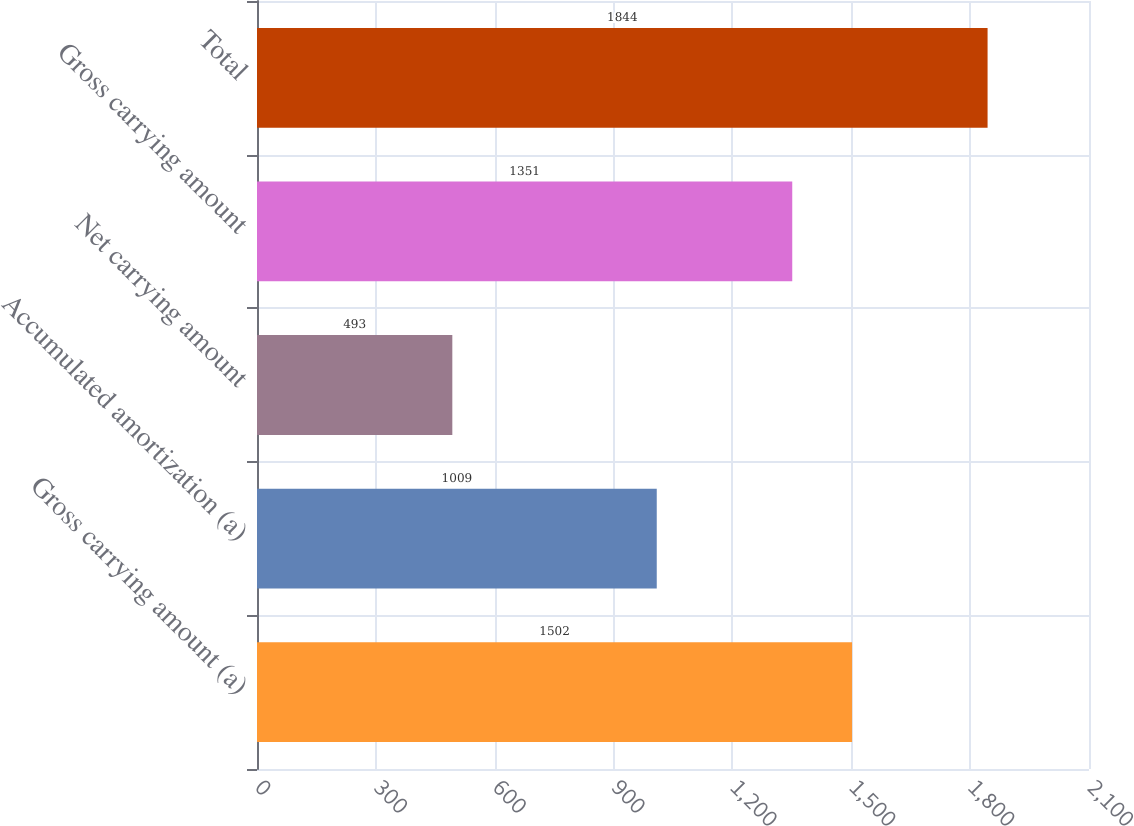Convert chart. <chart><loc_0><loc_0><loc_500><loc_500><bar_chart><fcel>Gross carrying amount (a)<fcel>Accumulated amortization (a)<fcel>Net carrying amount<fcel>Gross carrying amount<fcel>Total<nl><fcel>1502<fcel>1009<fcel>493<fcel>1351<fcel>1844<nl></chart> 